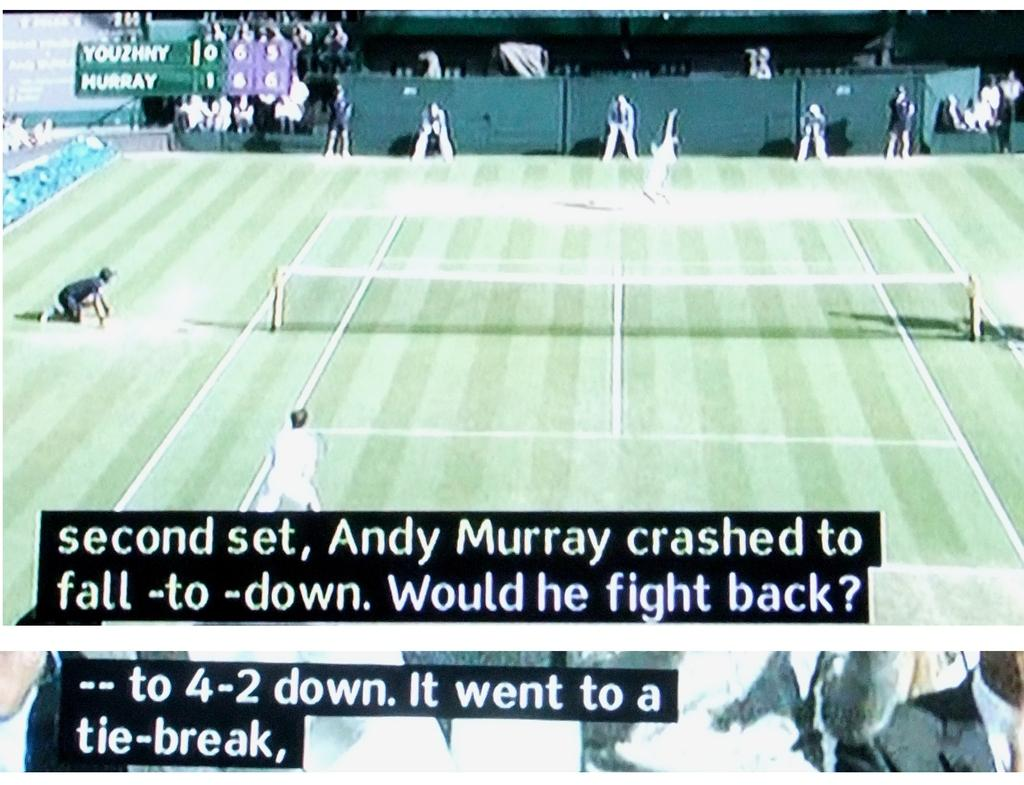Provide a one-sentence caption for the provided image. A tennis match between Youzhny and Murray is subtitled. 